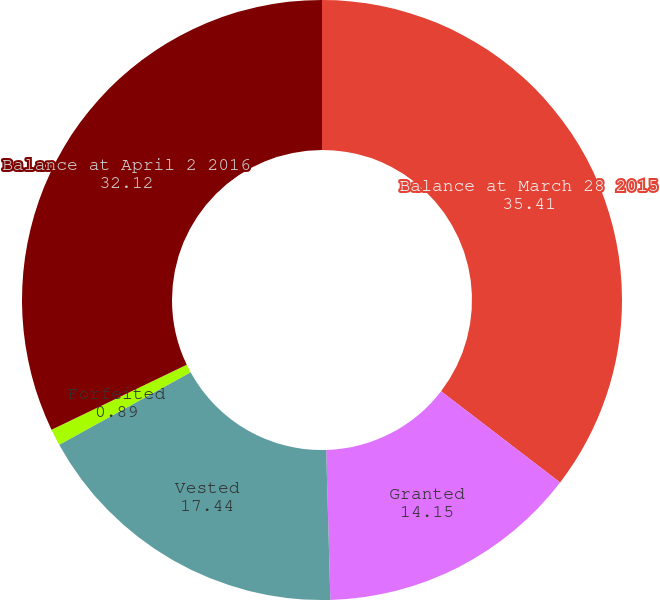Convert chart to OTSL. <chart><loc_0><loc_0><loc_500><loc_500><pie_chart><fcel>Balance at March 28 2015<fcel>Granted<fcel>Vested<fcel>Forfeited<fcel>Balance at April 2 2016<nl><fcel>35.41%<fcel>14.15%<fcel>17.44%<fcel>0.89%<fcel>32.12%<nl></chart> 